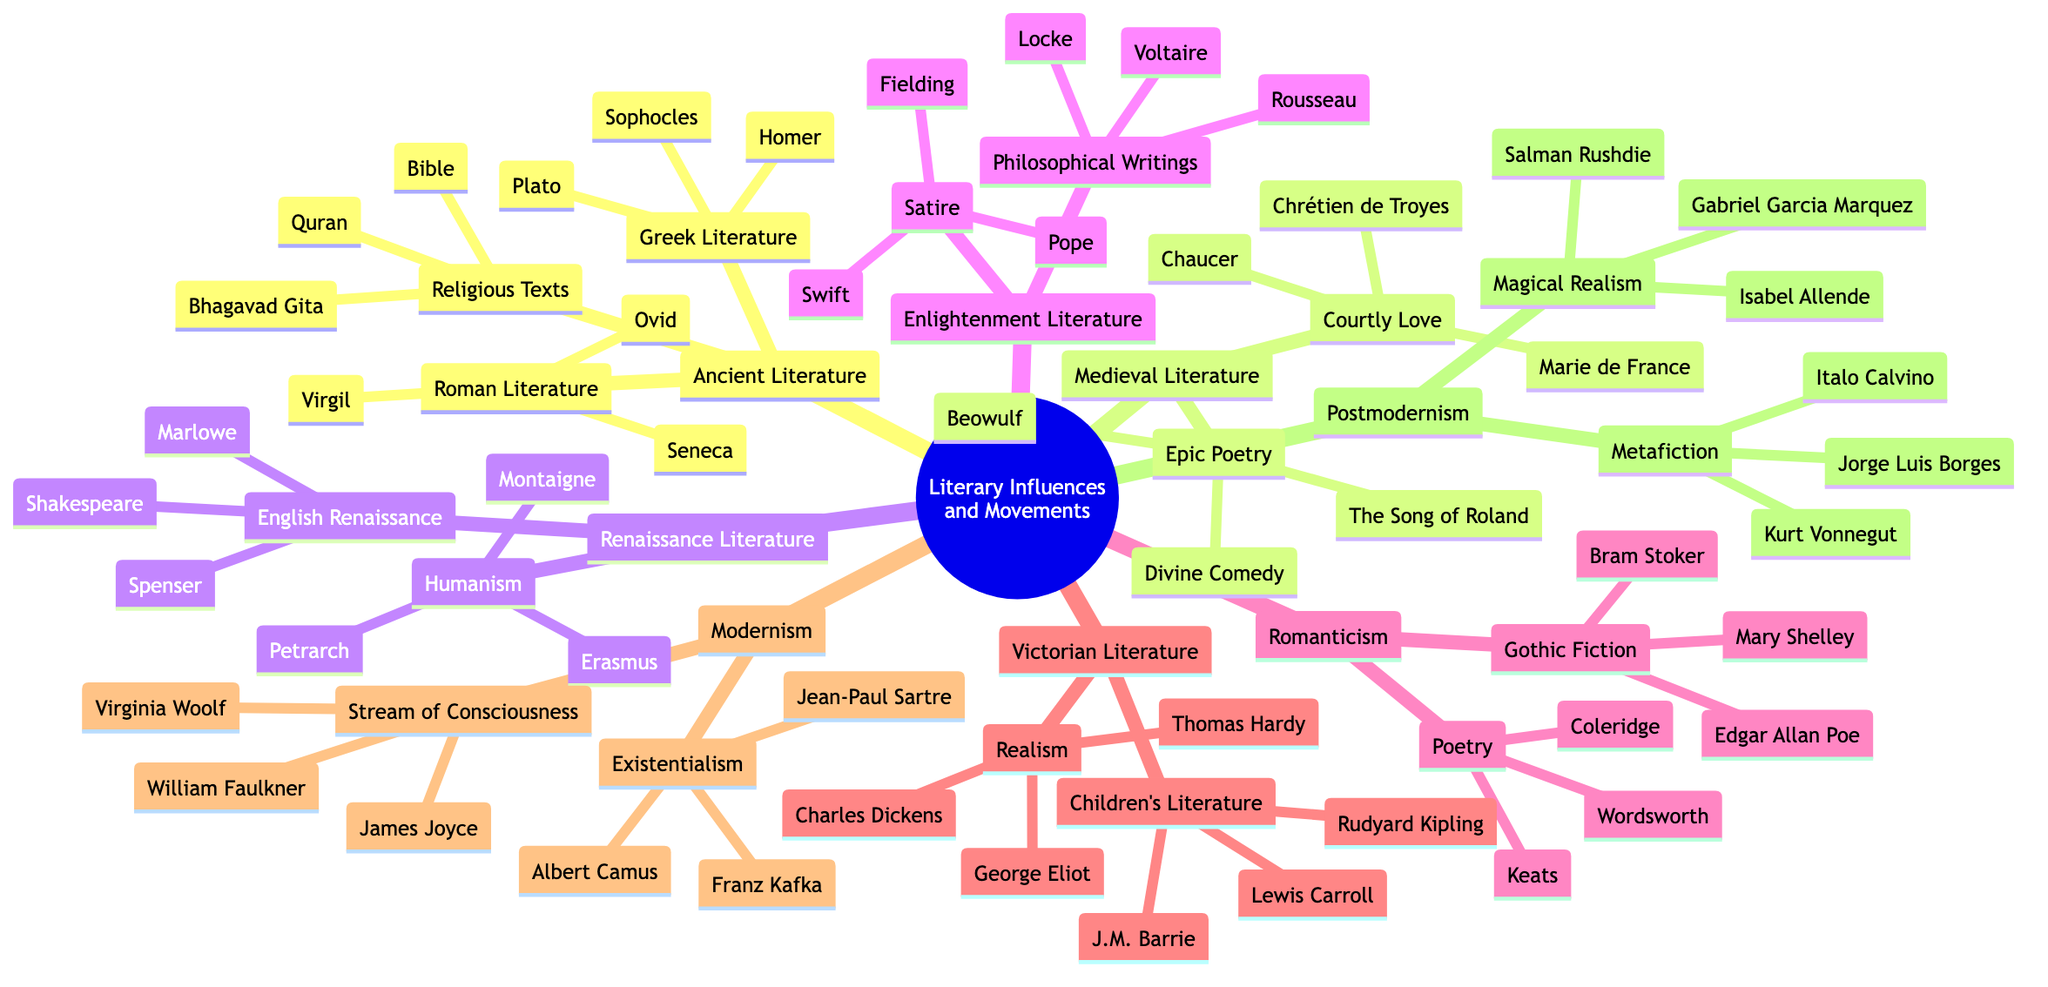What are the three main categories of Ancient Literature? The mind map shows three subdivisions under Ancient Literature: Greek Literature, Roman Literature, and Religious Texts. Therefore, these are the three main categories.
Answer: Greek Literature, Roman Literature, Religious Texts Which poet is associated with Epic Poetry in Medieval Literature? The diagram indicates that Beowulf is listed under Epic Poetry in the Medieval Literature section, making it the associated work.
Answer: Beowulf How many authors are listed under the Romanticism category? Under Romanticism, there are two subcategories: Poetry and Gothic Fiction. Each of these has three authors listed (Wordsworth, Coleridge, Keats for Poetry, and Mary Shelley, Edgar Allan Poe, Bram Stoker for Gothic Fiction), totaling six authors.
Answer: 6 Who wrote "Divine Comedy"? According to the mind map, Divine Comedy is listed under the Epic Poetry category of Medieval Literature. It indicates Dante Alighieri as the author, as he is the well-known writer of that work.
Answer: Dante Alighieri What literary movement includes "Magical Realism"? The mind map places Magical Realism under the Postmodernism category. By identifying the structure, it's evident that it corresponds to the Postmodernism movement.
Answer: Postmodernism Which two authors are part of the Existentialism subcategory in Modernism? In the diagram, Existentialism includes three authors: Franz Kafka, Albert Camus, and Jean-Paul Sartre. Selecting any two of these will answer the question, but listing them gives clarity.
Answer: Franz Kafka, Albert Camus Name a representative work of Victorian Realism. The mind map indicates that under the Victorian Literature category, Realism has three authors, including Charles Dickens, known for his novels which are representative of this movement.
Answer: Charles Dickens What type of writing is associated with Enlightenment Literature? Enlightenment Literature is divided into two main types: Philosophical Writings and Satire. This indicates that both are significant in this literary movement.
Answer: Philosophical Writings, Satire Which author's work is classified under Gothic Fiction? The diagram shows that under the Gothic Fiction subcategory in Romanticism are Mary Shelley, Edgar Allan Poe, and Bram Stoker. Therefore, one of these authors represents Gothic Fiction.
Answer: Mary Shelley 